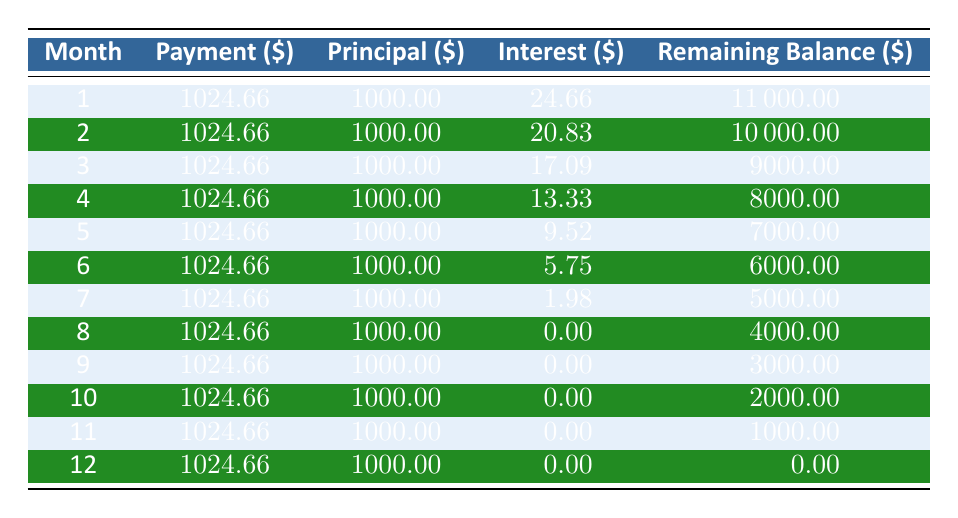What is the total payment amount made in the first three months? The payments for the first three months are 1024.66 each. Adding these amounts together gives: 1024.66 + 1024.66 + 1024.66 = 3073.98.
Answer: 3073.98 In which month does the interest amount first drop to zero? From the table, the interest amount is 1.98 in month 7, and it becomes 0.00 starting in month 8. Hence, it first drops to zero in month 8.
Answer: Month 8 How much total interest is paid over the entire grant term? To find the total interest, we must add the interest amounts from all months: 24.66 + 20.83 + 17.09 + 13.33 + 9.52 + 5.75 + 1.98 + 0.00 + 0.00 + 0.00 + 0.00 + 0.00 = 93.16.
Answer: 93.16 What is the remaining balance after the fourth month? According to the table, the remaining balance after the fourth month is shown as 8000.00.
Answer: 8000.00 Is the principal payment consistent every month? By reviewing the table, the principal payment is consistently 1000.00 each month across all twelve months, confirming that it is consistent.
Answer: Yes What is the average monthly payment across the entire grant term? The monthly payment is fixed at 1024.66 for all 12 months. Hence, the average is 1024.66.
Answer: 1024.66 What month shows the highest interest payment? The interest payment is highest in month 1 at 24.66, as the values decrease steadily each month.
Answer: Month 1 How much was the total principal paid at the end of the grant term? The principal payment each month is 1000.00 for 12 months. Therefore, total principal = 1000.00 * 12 = 12000.00.
Answer: 12000.00 Which month has the lowest remaining balance? The remaining balance reduces to zero at the end of month 12, indicating it is the lowest remaining balance after all payments are completed.
Answer: Month 12 